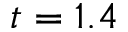Convert formula to latex. <formula><loc_0><loc_0><loc_500><loc_500>t = 1 . 4</formula> 